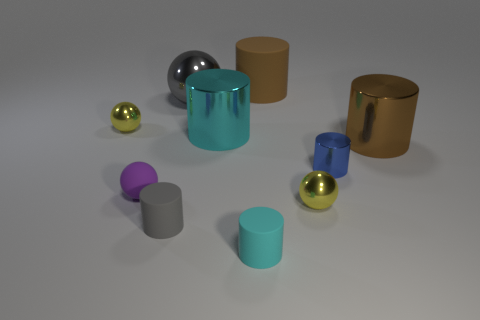How many other things are the same shape as the small cyan thing?
Offer a terse response. 5. Are any blue metal spheres visible?
Offer a very short reply. No. How many things are either spheres or yellow things that are right of the small cyan rubber object?
Your answer should be compact. 4. There is a gray object that is behind the purple rubber thing; is it the same size as the brown metal cylinder?
Your answer should be compact. Yes. What number of other objects are there of the same size as the purple object?
Give a very brief answer. 5. The big rubber thing is what color?
Your response must be concise. Brown. There is a big cylinder that is behind the big sphere; what is its material?
Your answer should be very brief. Rubber. Is the number of cyan things that are in front of the small cyan thing the same as the number of cyan spheres?
Give a very brief answer. Yes. Does the small blue shiny object have the same shape as the tiny purple matte object?
Keep it short and to the point. No. Are there any other things of the same color as the small shiny cylinder?
Ensure brevity in your answer.  No. 